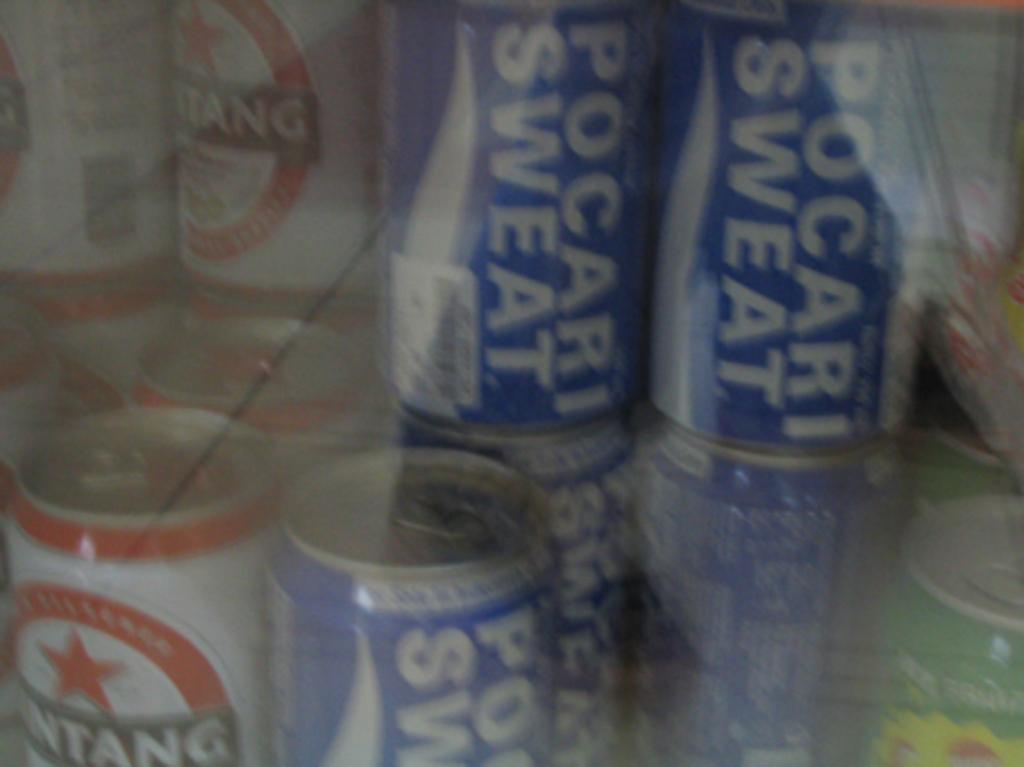What is in the blue cans?
Offer a very short reply. Pocari sweat. 